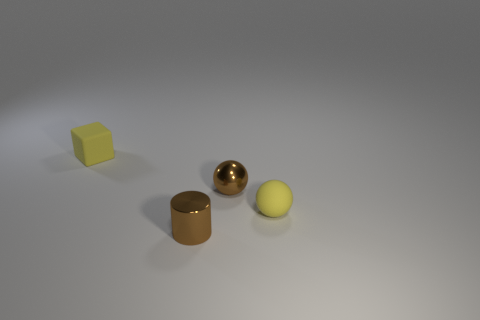Add 4 rubber objects. How many objects exist? 8 Subtract all blocks. How many objects are left? 3 Subtract all tiny matte objects. Subtract all small brown metal things. How many objects are left? 0 Add 3 yellow spheres. How many yellow spheres are left? 4 Add 4 small cylinders. How many small cylinders exist? 5 Subtract 0 blue cylinders. How many objects are left? 4 